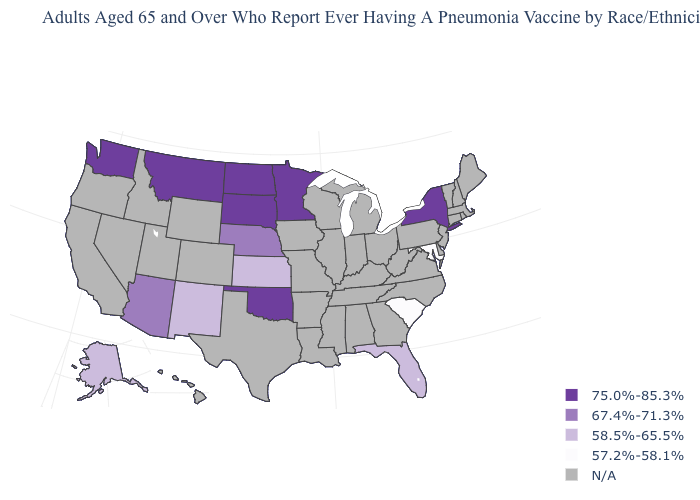What is the value of Nevada?
Give a very brief answer. N/A. Which states have the lowest value in the MidWest?
Short answer required. Kansas. What is the lowest value in the USA?
Keep it brief. 57.2%-58.1%. Name the states that have a value in the range 75.0%-85.3%?
Short answer required. Minnesota, Montana, New York, North Dakota, Oklahoma, South Dakota, Washington. Does the first symbol in the legend represent the smallest category?
Concise answer only. No. Name the states that have a value in the range 75.0%-85.3%?
Short answer required. Minnesota, Montana, New York, North Dakota, Oklahoma, South Dakota, Washington. Which states have the lowest value in the Northeast?
Quick response, please. New York. What is the value of Utah?
Be succinct. N/A. What is the lowest value in the MidWest?
Write a very short answer. 58.5%-65.5%. Which states hav the highest value in the South?
Short answer required. Oklahoma. Does Alaska have the highest value in the West?
Give a very brief answer. No. 